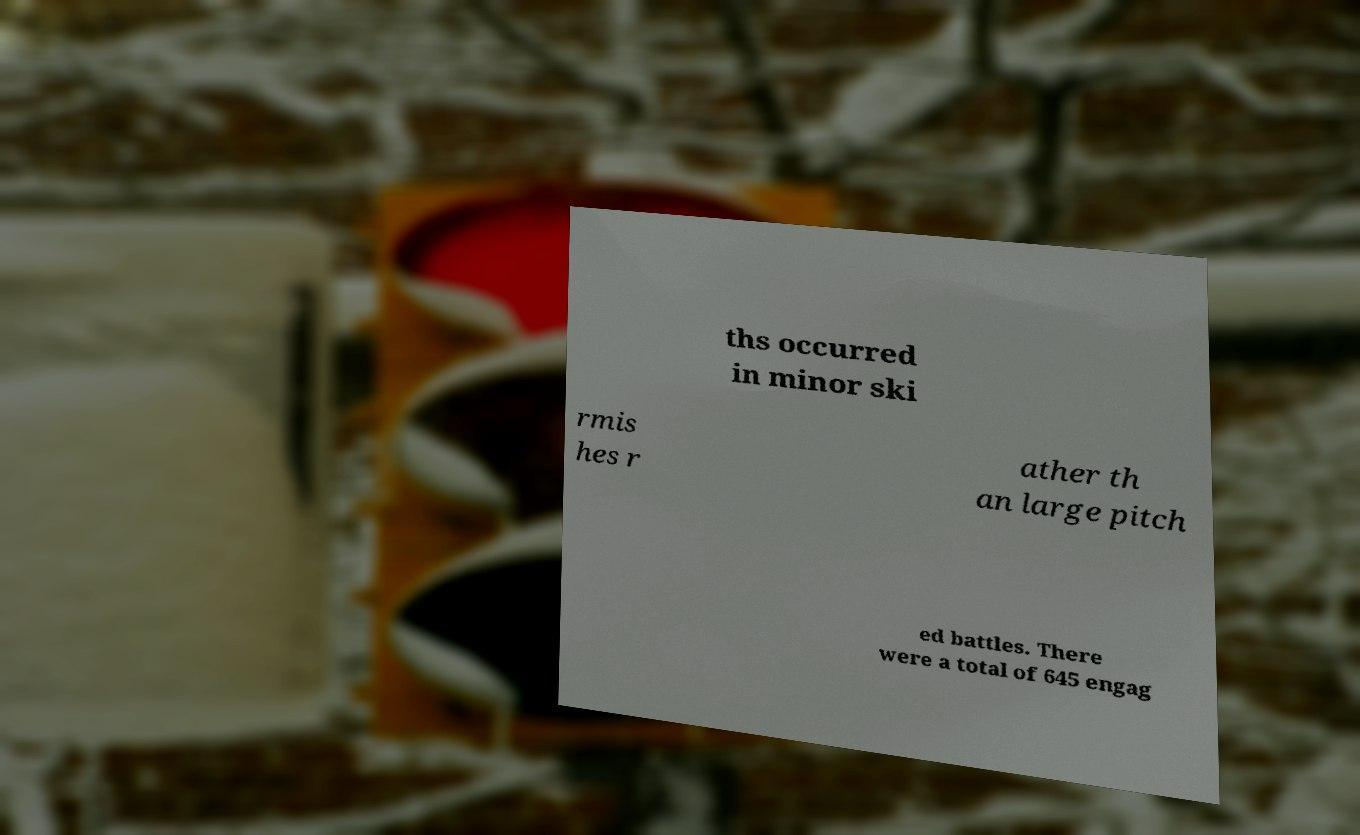What messages or text are displayed in this image? I need them in a readable, typed format. ths occurred in minor ski rmis hes r ather th an large pitch ed battles. There were a total of 645 engag 